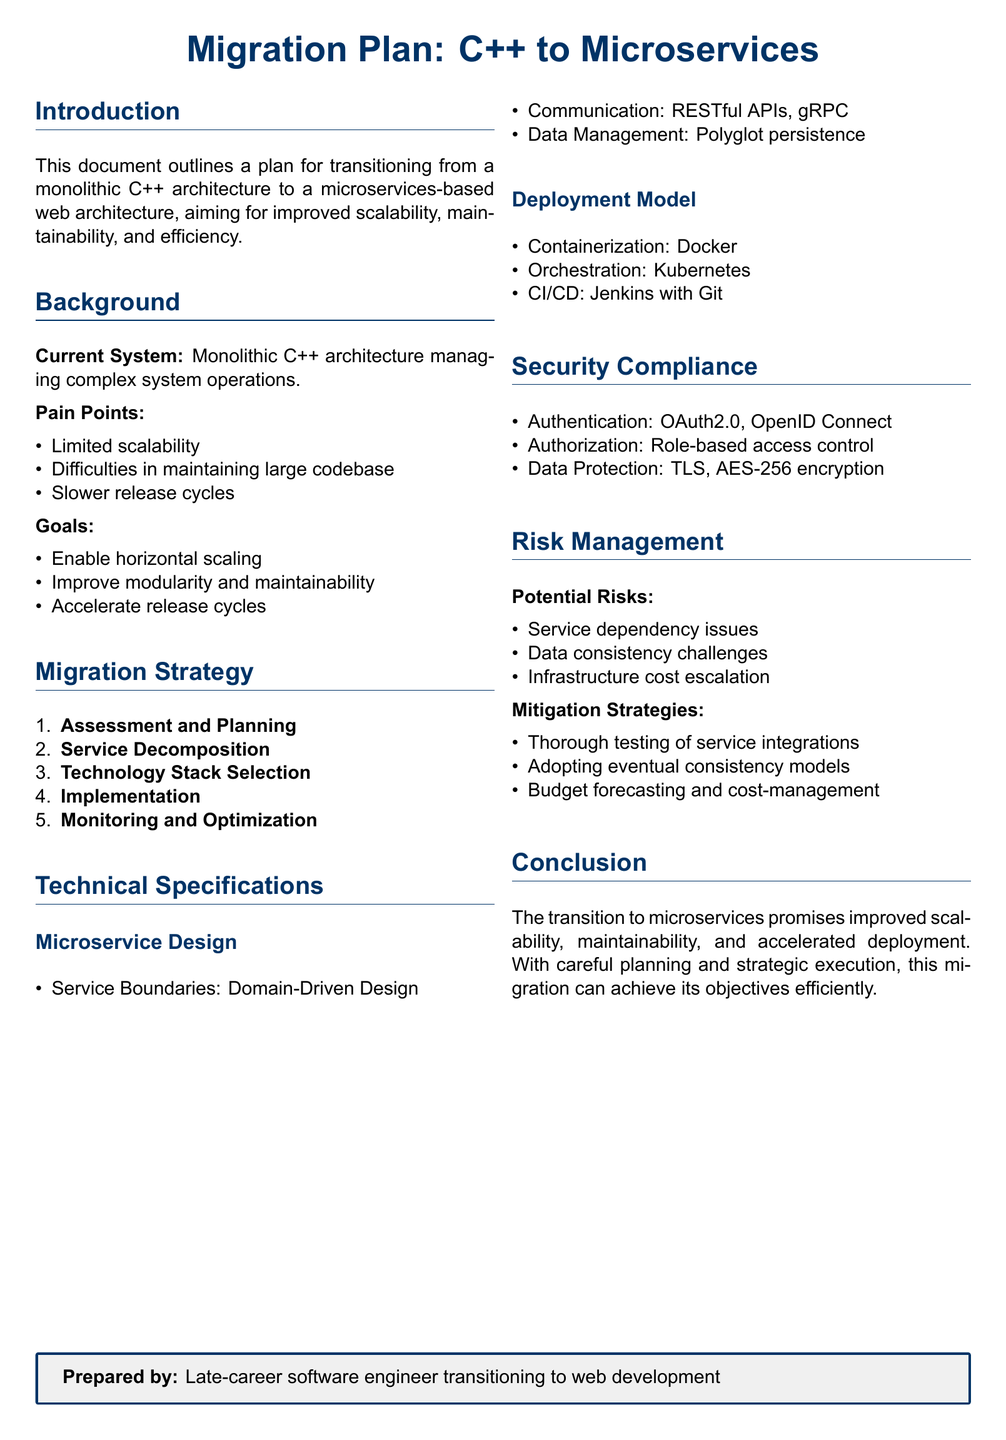What is the main goal of the migration plan? The main goal of the migration plan is to improve scalability, maintainability, and efficiency.
Answer: Improve scalability, maintainability, and efficiency What are the first two steps in the migration strategy? The first two steps in the migration strategy are Assessment and Planning and Service Decomposition.
Answer: Assessment and Planning, Service Decomposition What technologies are suggested for deployment? Suggested technologies for deployment include Docker, Kubernetes, and Jenkins with Git.
Answer: Docker, Kubernetes, Jenkins with Git What is one potential risk listed in the document? One potential risk listed in the document is service dependency issues.
Answer: Service dependency issues What is the authentication method mentioned for security compliance? The authentication method mentioned for security compliance is OAuth2.0 and OpenID Connect.
Answer: OAuth2.0, OpenID Connect Which design approach is recommended for microservice boundaries? The recommended design approach for microservice boundaries is Domain-Driven Design.
Answer: Domain-Driven Design What aspect of the migration plan focuses on optimizing performance? The aspect focusing on optimizing performance is Monitoring and Optimization.
Answer: Monitoring and Optimization What is the purpose of polyglot persistence in data management? Polyglot persistence is used for managing data across different services in a microservices architecture.
Answer: Managing data across different services 